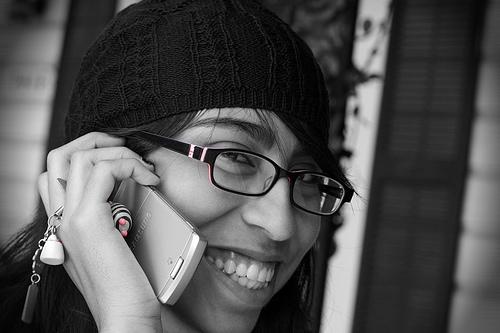What is the girl holding over her head?
Answer briefly. Phone. What is this woman holding up to her ear?
Concise answer only. Cell phone. Is this woman looking at the camera?
Be succinct. Yes. What is on the woman's face?
Write a very short answer. Glasses. 